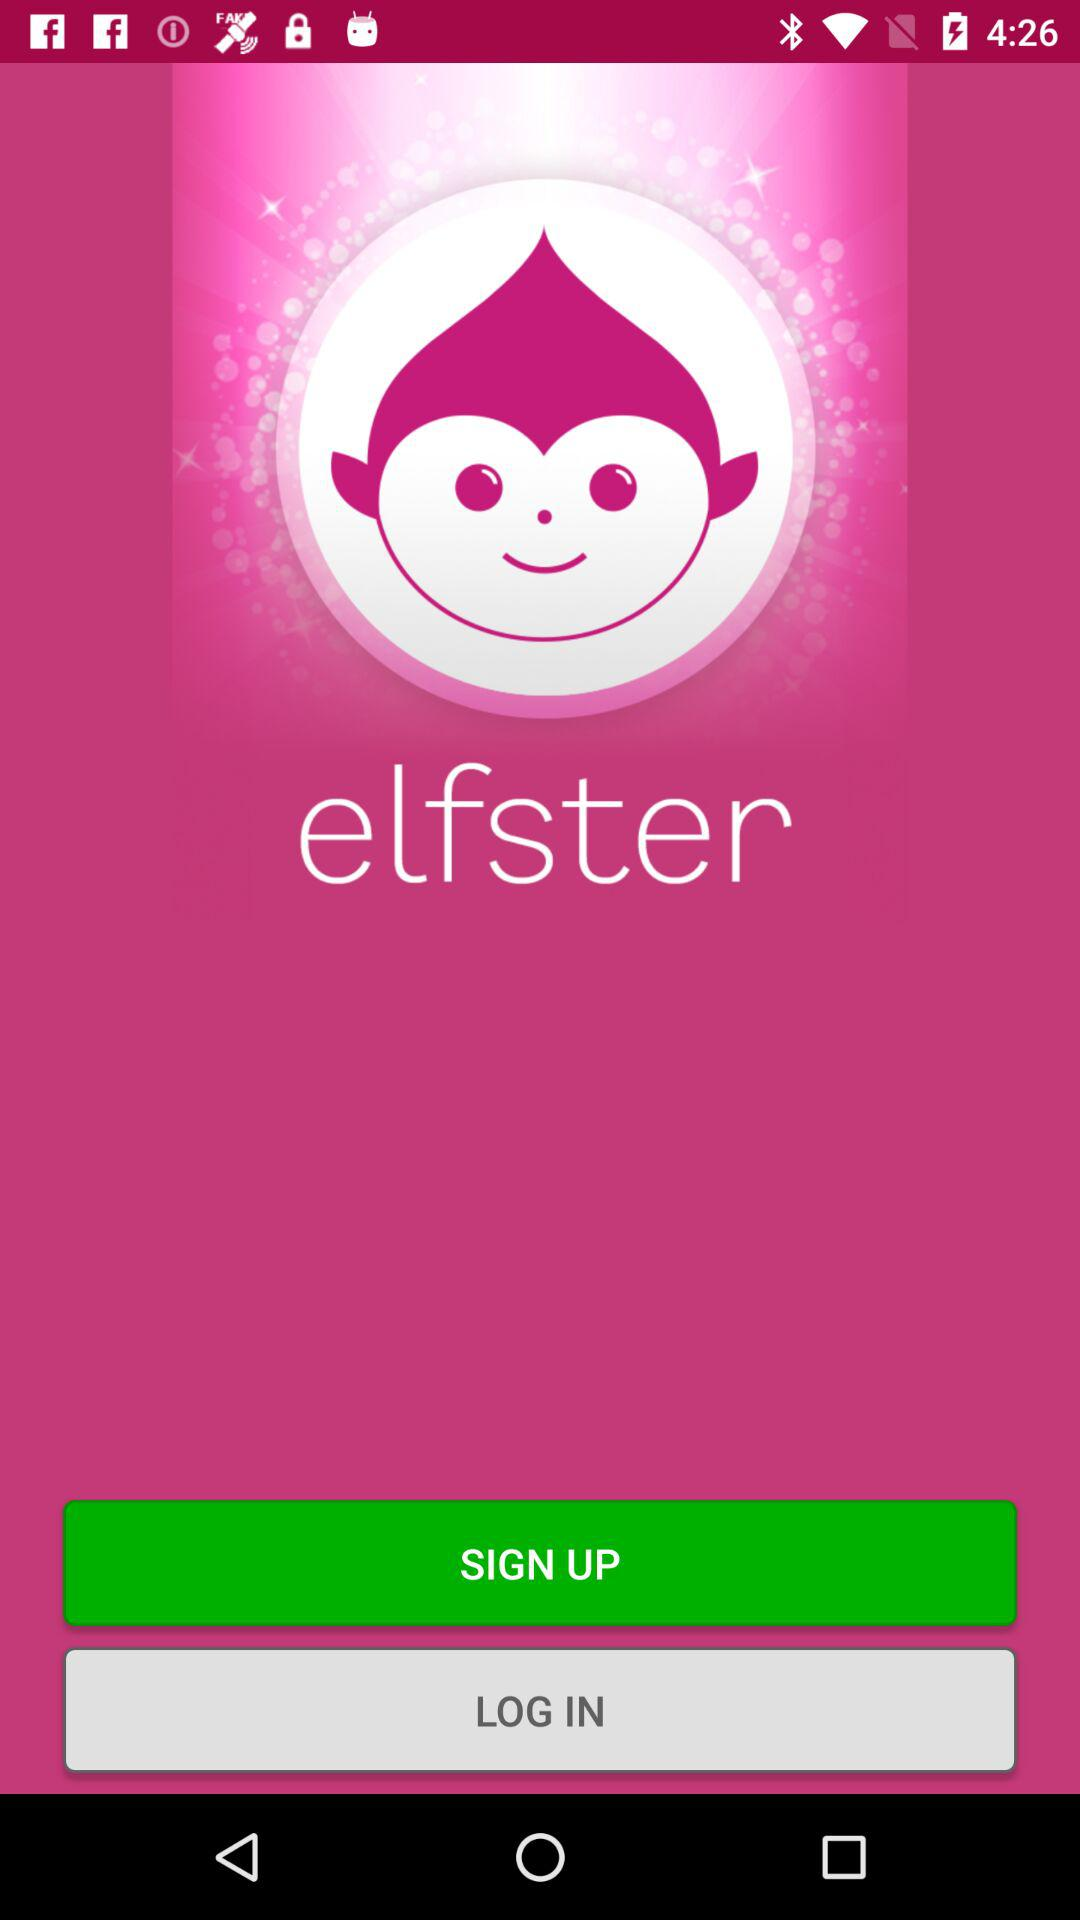What is the application name? The application name is "elfster". 